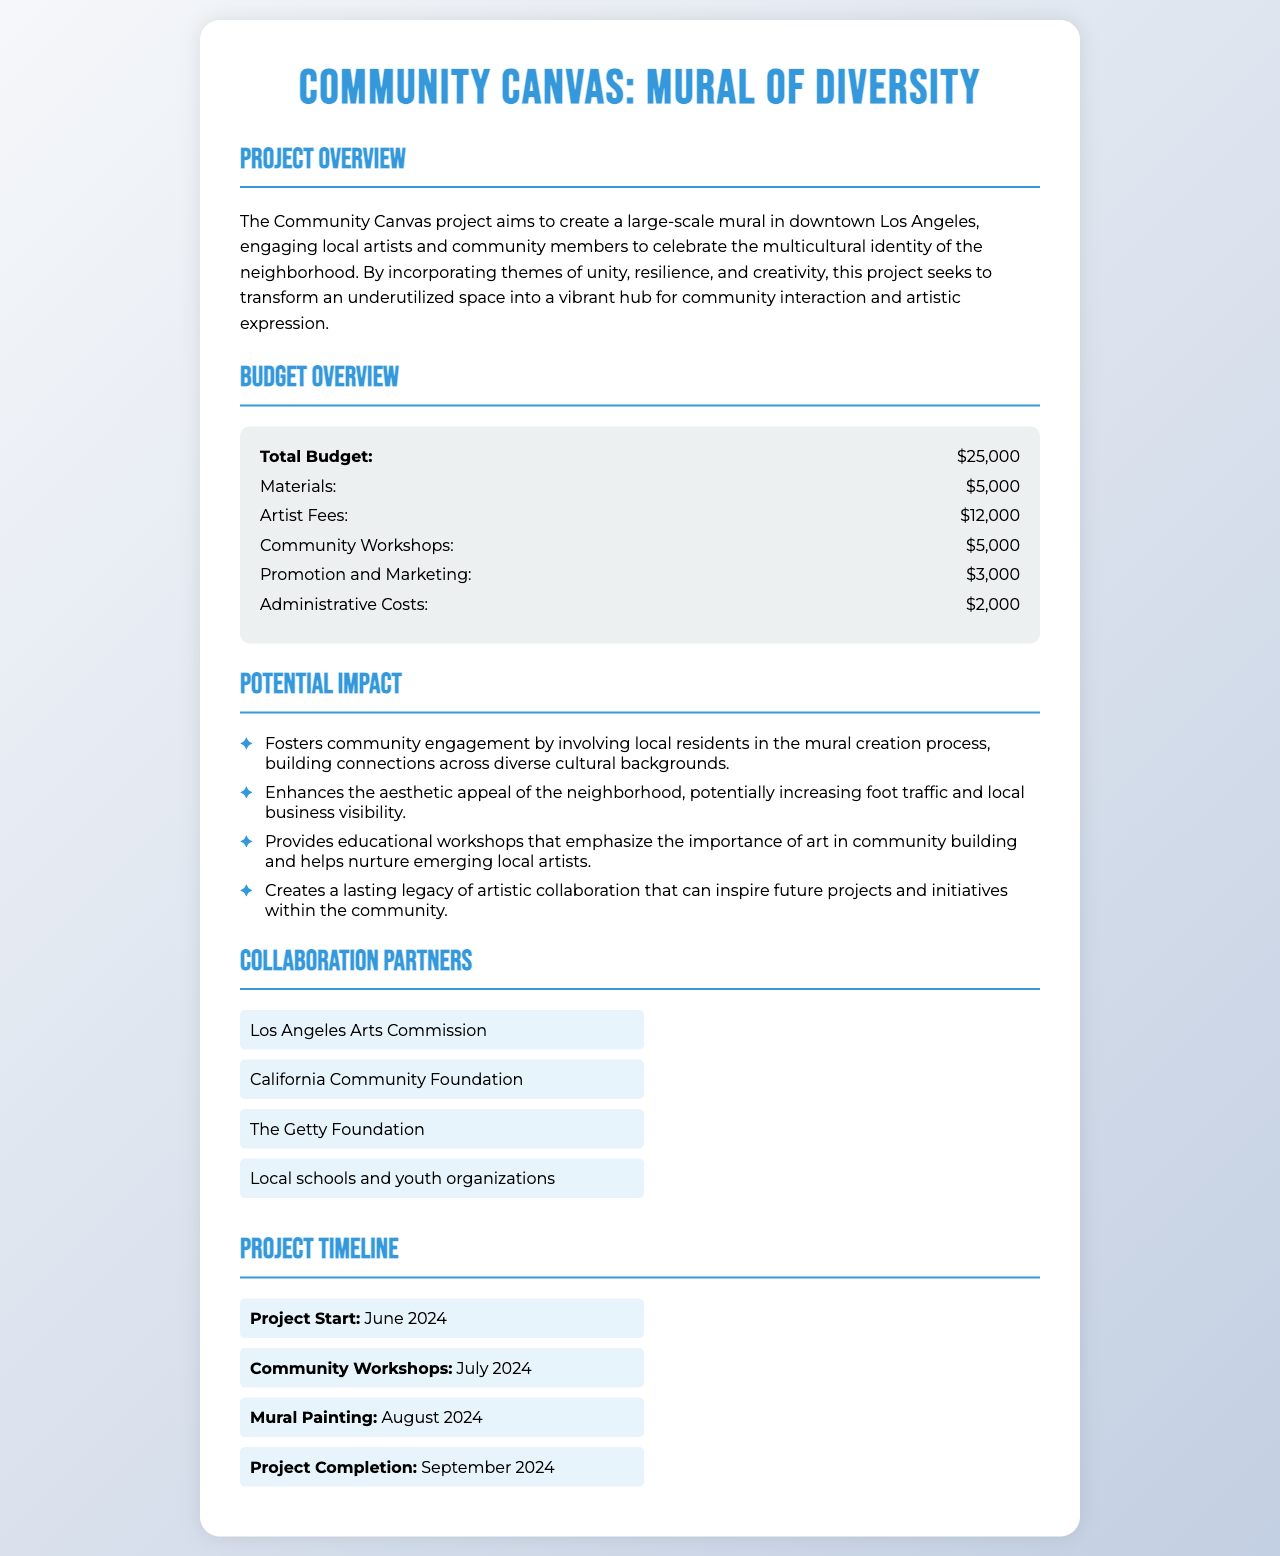What is the project title? The project title is mentioned at the top of the document as a prominent headline.
Answer: Community Canvas: Mural of Diversity What is the total budget for the project? The total budget is specified clearly in the budget overview section.
Answer: $25,000 When does the project start? The project start date is provided in the project timeline section.
Answer: June 2024 How much is allocated for artist fees? The amount for artist fees is detailed in the budget itemization.
Answer: $12,000 What is one potential impact of the project? The potential impacts are listed, and the question seeks one example from those stated.
Answer: Fosters community engagement Which organization is listed as a collaboration partner? Several collaboration partners are mentioned; the question seeks to name one of them.
Answer: Los Angeles Arts Commission What month is the mural painting scheduled for? The specific month for the mural painting is outlined in the project timeline.
Answer: August 2024 How much funding is set aside for materials? The budget overview explicitly states the allocation for materials.
Answer: $5,000 What theme does the mural focus on? The project overview describes the thematic focus of the mural.
Answer: Multicultural identity 